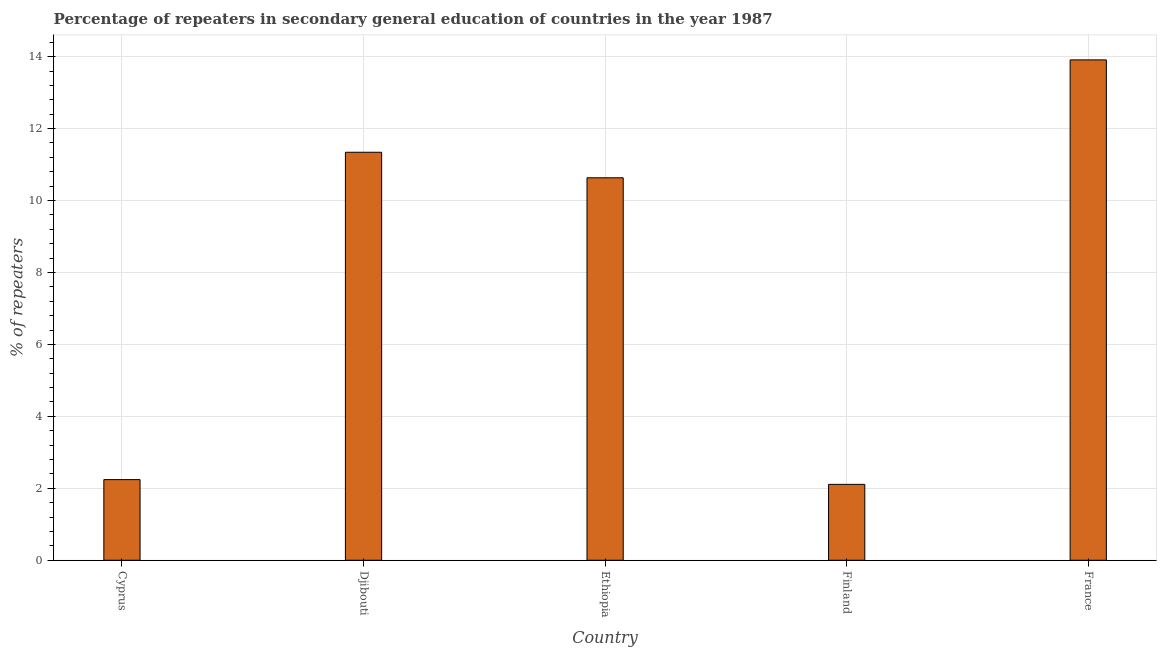What is the title of the graph?
Offer a terse response. Percentage of repeaters in secondary general education of countries in the year 1987. What is the label or title of the Y-axis?
Give a very brief answer. % of repeaters. What is the percentage of repeaters in Finland?
Keep it short and to the point. 2.11. Across all countries, what is the maximum percentage of repeaters?
Your answer should be compact. 13.91. Across all countries, what is the minimum percentage of repeaters?
Give a very brief answer. 2.11. What is the sum of the percentage of repeaters?
Offer a very short reply. 40.24. What is the difference between the percentage of repeaters in Djibouti and France?
Your answer should be very brief. -2.57. What is the average percentage of repeaters per country?
Keep it short and to the point. 8.05. What is the median percentage of repeaters?
Ensure brevity in your answer.  10.63. In how many countries, is the percentage of repeaters greater than 0.4 %?
Make the answer very short. 5. What is the ratio of the percentage of repeaters in Djibouti to that in Finland?
Make the answer very short. 5.38. Is the percentage of repeaters in Djibouti less than that in Finland?
Provide a short and direct response. No. Is the difference between the percentage of repeaters in Ethiopia and Finland greater than the difference between any two countries?
Provide a succinct answer. No. What is the difference between the highest and the second highest percentage of repeaters?
Give a very brief answer. 2.57. Is the sum of the percentage of repeaters in Ethiopia and France greater than the maximum percentage of repeaters across all countries?
Offer a very short reply. Yes. What is the difference between the highest and the lowest percentage of repeaters?
Give a very brief answer. 11.8. What is the difference between two consecutive major ticks on the Y-axis?
Keep it short and to the point. 2. What is the % of repeaters of Cyprus?
Ensure brevity in your answer.  2.24. What is the % of repeaters of Djibouti?
Make the answer very short. 11.34. What is the % of repeaters in Ethiopia?
Give a very brief answer. 10.63. What is the % of repeaters in Finland?
Your response must be concise. 2.11. What is the % of repeaters of France?
Provide a short and direct response. 13.91. What is the difference between the % of repeaters in Cyprus and Djibouti?
Ensure brevity in your answer.  -9.1. What is the difference between the % of repeaters in Cyprus and Ethiopia?
Offer a terse response. -8.39. What is the difference between the % of repeaters in Cyprus and Finland?
Provide a short and direct response. 0.13. What is the difference between the % of repeaters in Cyprus and France?
Ensure brevity in your answer.  -11.67. What is the difference between the % of repeaters in Djibouti and Ethiopia?
Ensure brevity in your answer.  0.71. What is the difference between the % of repeaters in Djibouti and Finland?
Offer a terse response. 9.23. What is the difference between the % of repeaters in Djibouti and France?
Offer a terse response. -2.57. What is the difference between the % of repeaters in Ethiopia and Finland?
Offer a terse response. 8.52. What is the difference between the % of repeaters in Ethiopia and France?
Your answer should be compact. -3.28. What is the difference between the % of repeaters in Finland and France?
Ensure brevity in your answer.  -11.8. What is the ratio of the % of repeaters in Cyprus to that in Djibouti?
Your response must be concise. 0.2. What is the ratio of the % of repeaters in Cyprus to that in Ethiopia?
Your response must be concise. 0.21. What is the ratio of the % of repeaters in Cyprus to that in Finland?
Offer a very short reply. 1.06. What is the ratio of the % of repeaters in Cyprus to that in France?
Keep it short and to the point. 0.16. What is the ratio of the % of repeaters in Djibouti to that in Ethiopia?
Offer a very short reply. 1.07. What is the ratio of the % of repeaters in Djibouti to that in Finland?
Provide a short and direct response. 5.38. What is the ratio of the % of repeaters in Djibouti to that in France?
Provide a succinct answer. 0.81. What is the ratio of the % of repeaters in Ethiopia to that in Finland?
Make the answer very short. 5.04. What is the ratio of the % of repeaters in Ethiopia to that in France?
Give a very brief answer. 0.76. What is the ratio of the % of repeaters in Finland to that in France?
Your answer should be compact. 0.15. 